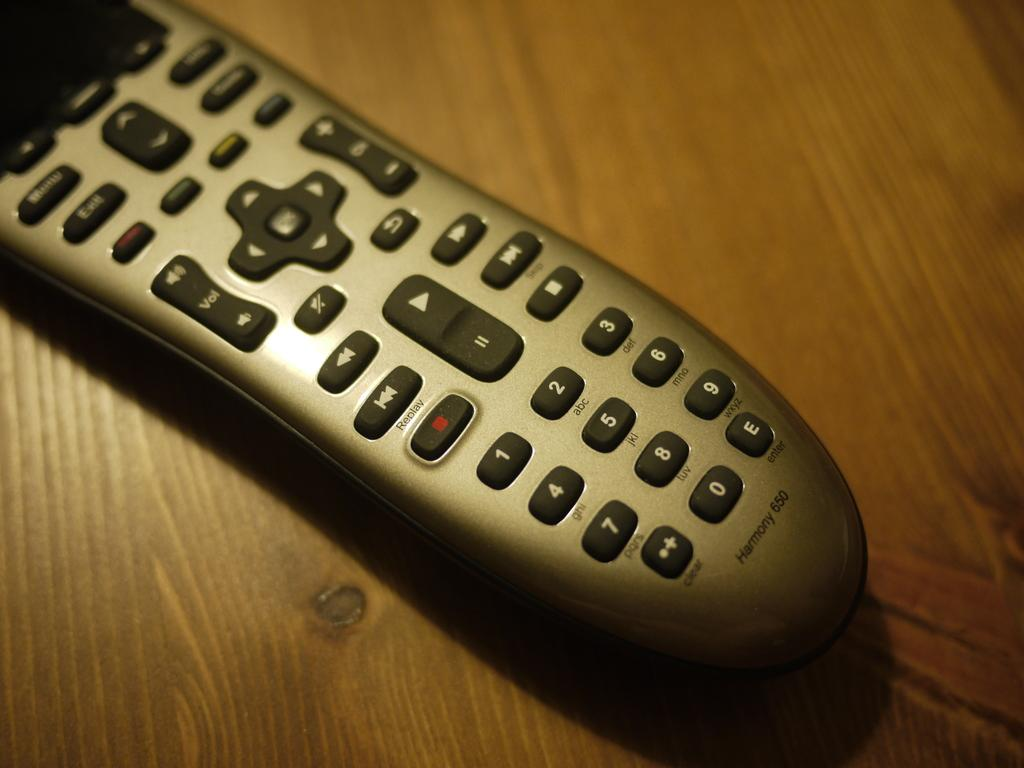What object can be seen in the image? There is a remote in the image. What is the remote placed on? The remote is on a wooden surface. What can be found on the remote? The remote has numbers, text, and symbols on it. Can you see any quills being used to write on the wooden surface in the image? No, there are no quills present in the image. 